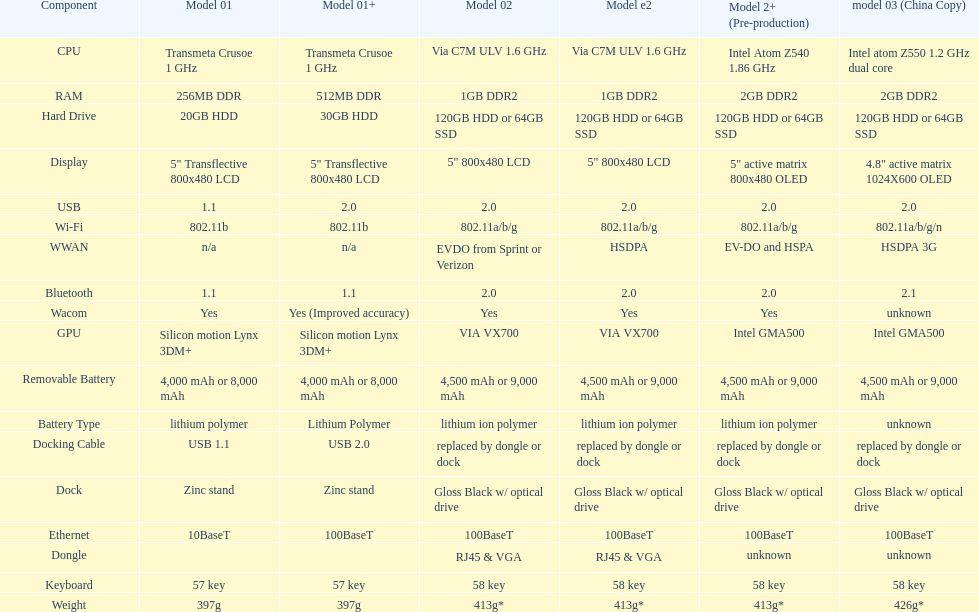What is the total number of components on the chart? 18. 